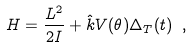Convert formula to latex. <formula><loc_0><loc_0><loc_500><loc_500>H = \frac { L ^ { 2 } } { 2 I } + { \hat { k } } V ( \theta ) \Delta _ { T } ( t ) \ ,</formula> 